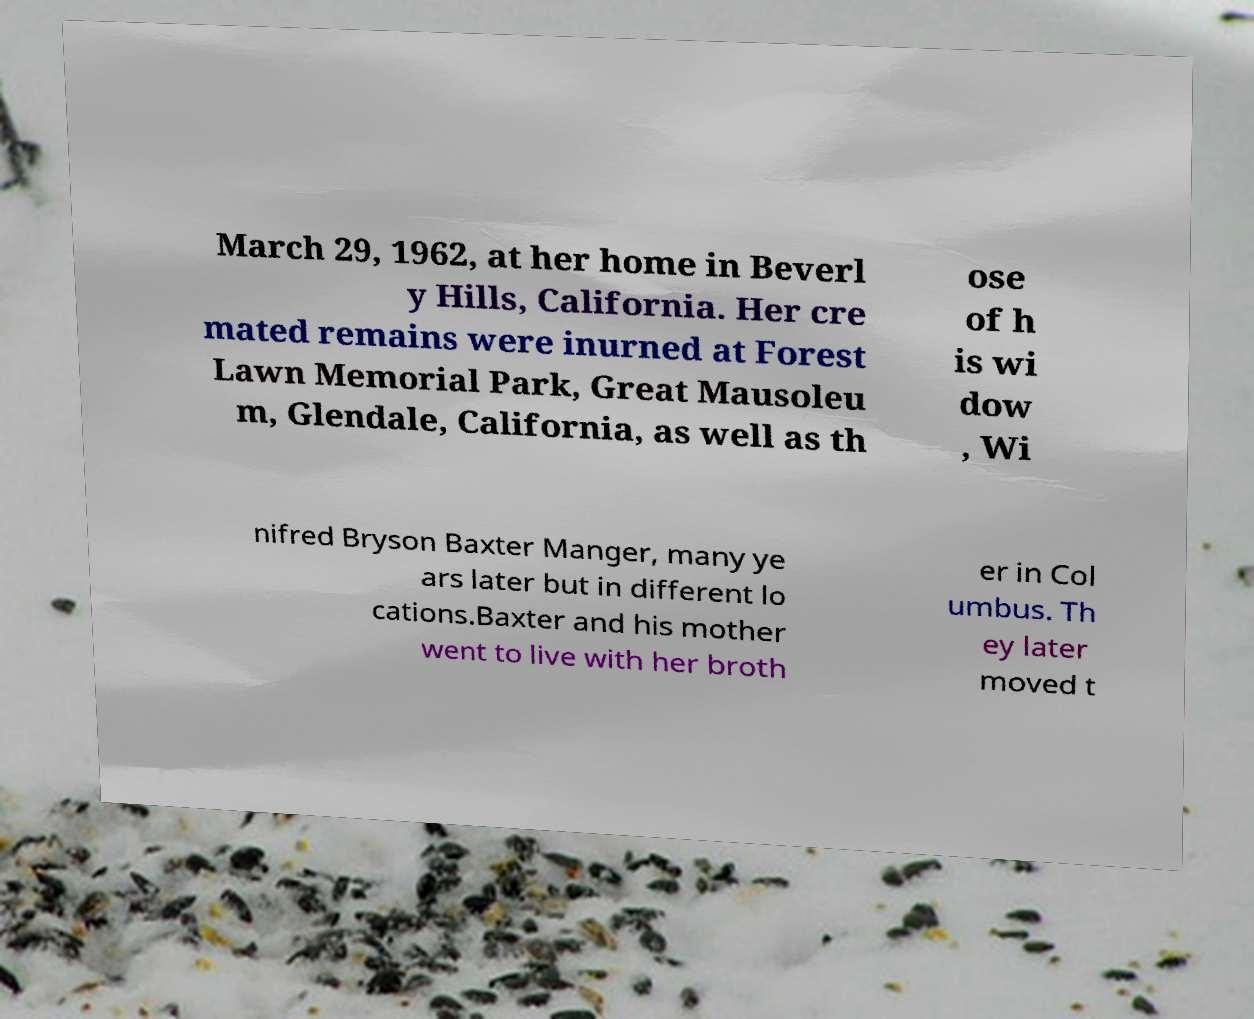Can you read and provide the text displayed in the image?This photo seems to have some interesting text. Can you extract and type it out for me? March 29, 1962, at her home in Beverl y Hills, California. Her cre mated remains were inurned at Forest Lawn Memorial Park, Great Mausoleu m, Glendale, California, as well as th ose of h is wi dow , Wi nifred Bryson Baxter Manger, many ye ars later but in different lo cations.Baxter and his mother went to live with her broth er in Col umbus. Th ey later moved t 